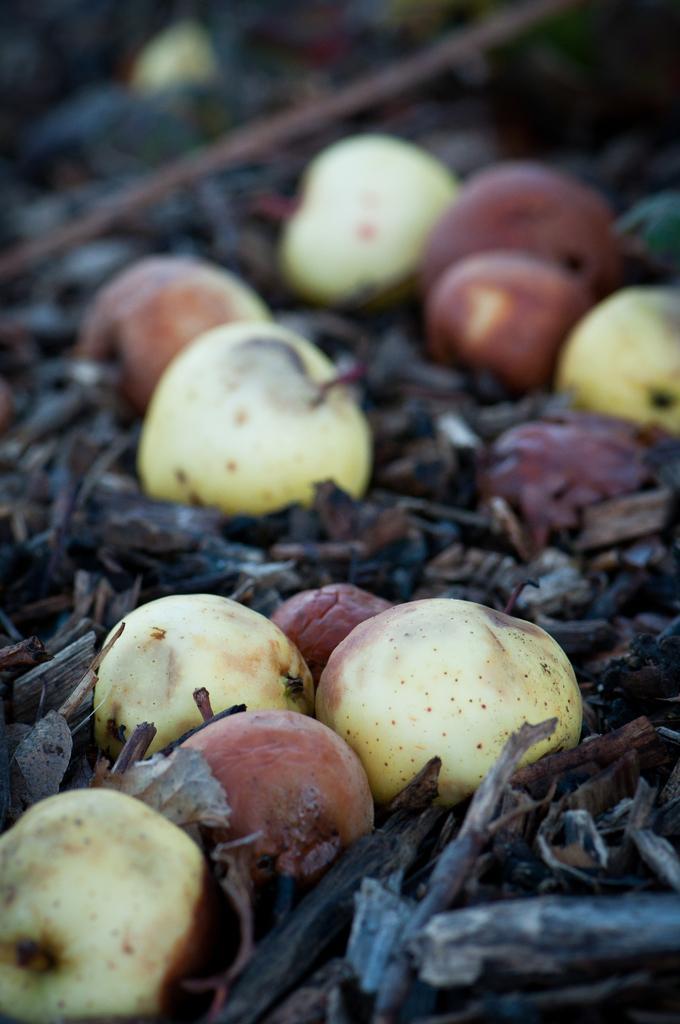Could you give a brief overview of what you see in this image? In this picture I can see some fruits are on the dry leaves and stems. 